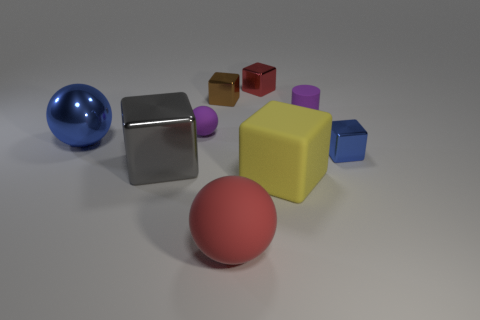The thing that is the same color as the big metal sphere is what shape?
Your answer should be very brief. Cube. How many tiny red shiny blocks are to the left of the red object in front of the big block that is in front of the large shiny block?
Your answer should be compact. 0. Is the number of large gray objects that are on the right side of the big blue sphere less than the number of things left of the red cube?
Keep it short and to the point. Yes. There is another matte thing that is the same shape as the red matte object; what is its color?
Your answer should be compact. Purple. What size is the gray shiny object?
Offer a terse response. Large. What number of yellow cubes have the same size as the gray thing?
Your answer should be very brief. 1. Do the matte cylinder and the tiny matte ball have the same color?
Make the answer very short. Yes. Do the red object in front of the yellow rubber cube and the blue object that is in front of the big blue shiny thing have the same material?
Ensure brevity in your answer.  No. Are there more big metallic balls than tiny blue spheres?
Give a very brief answer. Yes. Are there any other things of the same color as the tiny cylinder?
Offer a very short reply. Yes. 